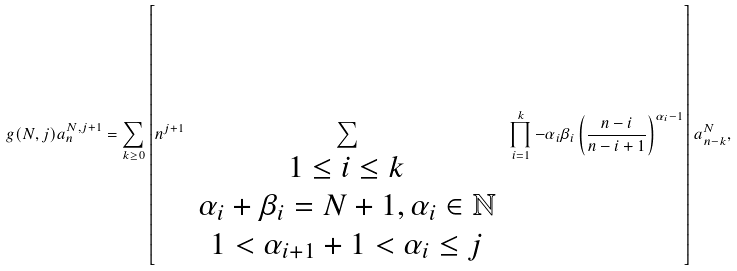Convert formula to latex. <formula><loc_0><loc_0><loc_500><loc_500>g ( N , j ) a _ { n } ^ { N , j + 1 } = \sum _ { k \geq 0 } \left [ n ^ { j + 1 } \, \sum _ { \begin{array} { c } 1 \leq i \leq k \\ \alpha _ { i } + \beta _ { i } = N + 1 , \alpha _ { i } \in \mathbb { N } \\ 1 < \alpha _ { i + 1 } + 1 < \alpha _ { i } \leq j \end{array} } \, \prod _ { i = 1 } ^ { k } - \alpha _ { i } \beta _ { i } \left ( \frac { n - i } { n - i + 1 } \right ) ^ { \alpha _ { i } - 1 } \right ] a _ { n - k } ^ { N } ,</formula> 